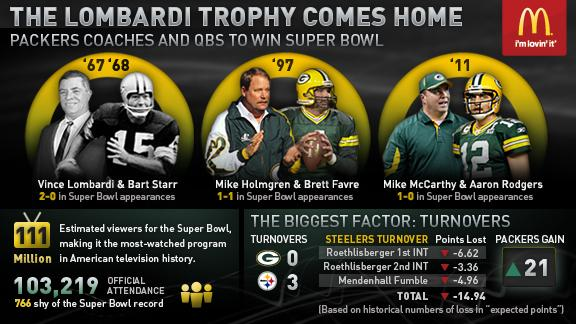Identify some key points in this picture. Vince Lombardi won the Lombardi trophy in 1967 and 1968. In 2011, Aaron Rodgers, the quarterback player, was the recipient of the Lombardi trophy. 